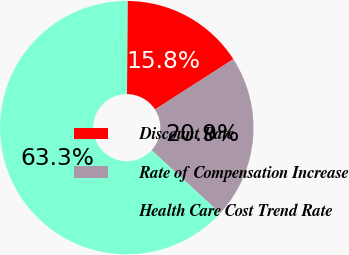<chart> <loc_0><loc_0><loc_500><loc_500><pie_chart><fcel>Discount Rate<fcel>Rate of Compensation Increase<fcel>Health Care Cost Trend Rate<nl><fcel>15.82%<fcel>20.89%<fcel>63.29%<nl></chart> 